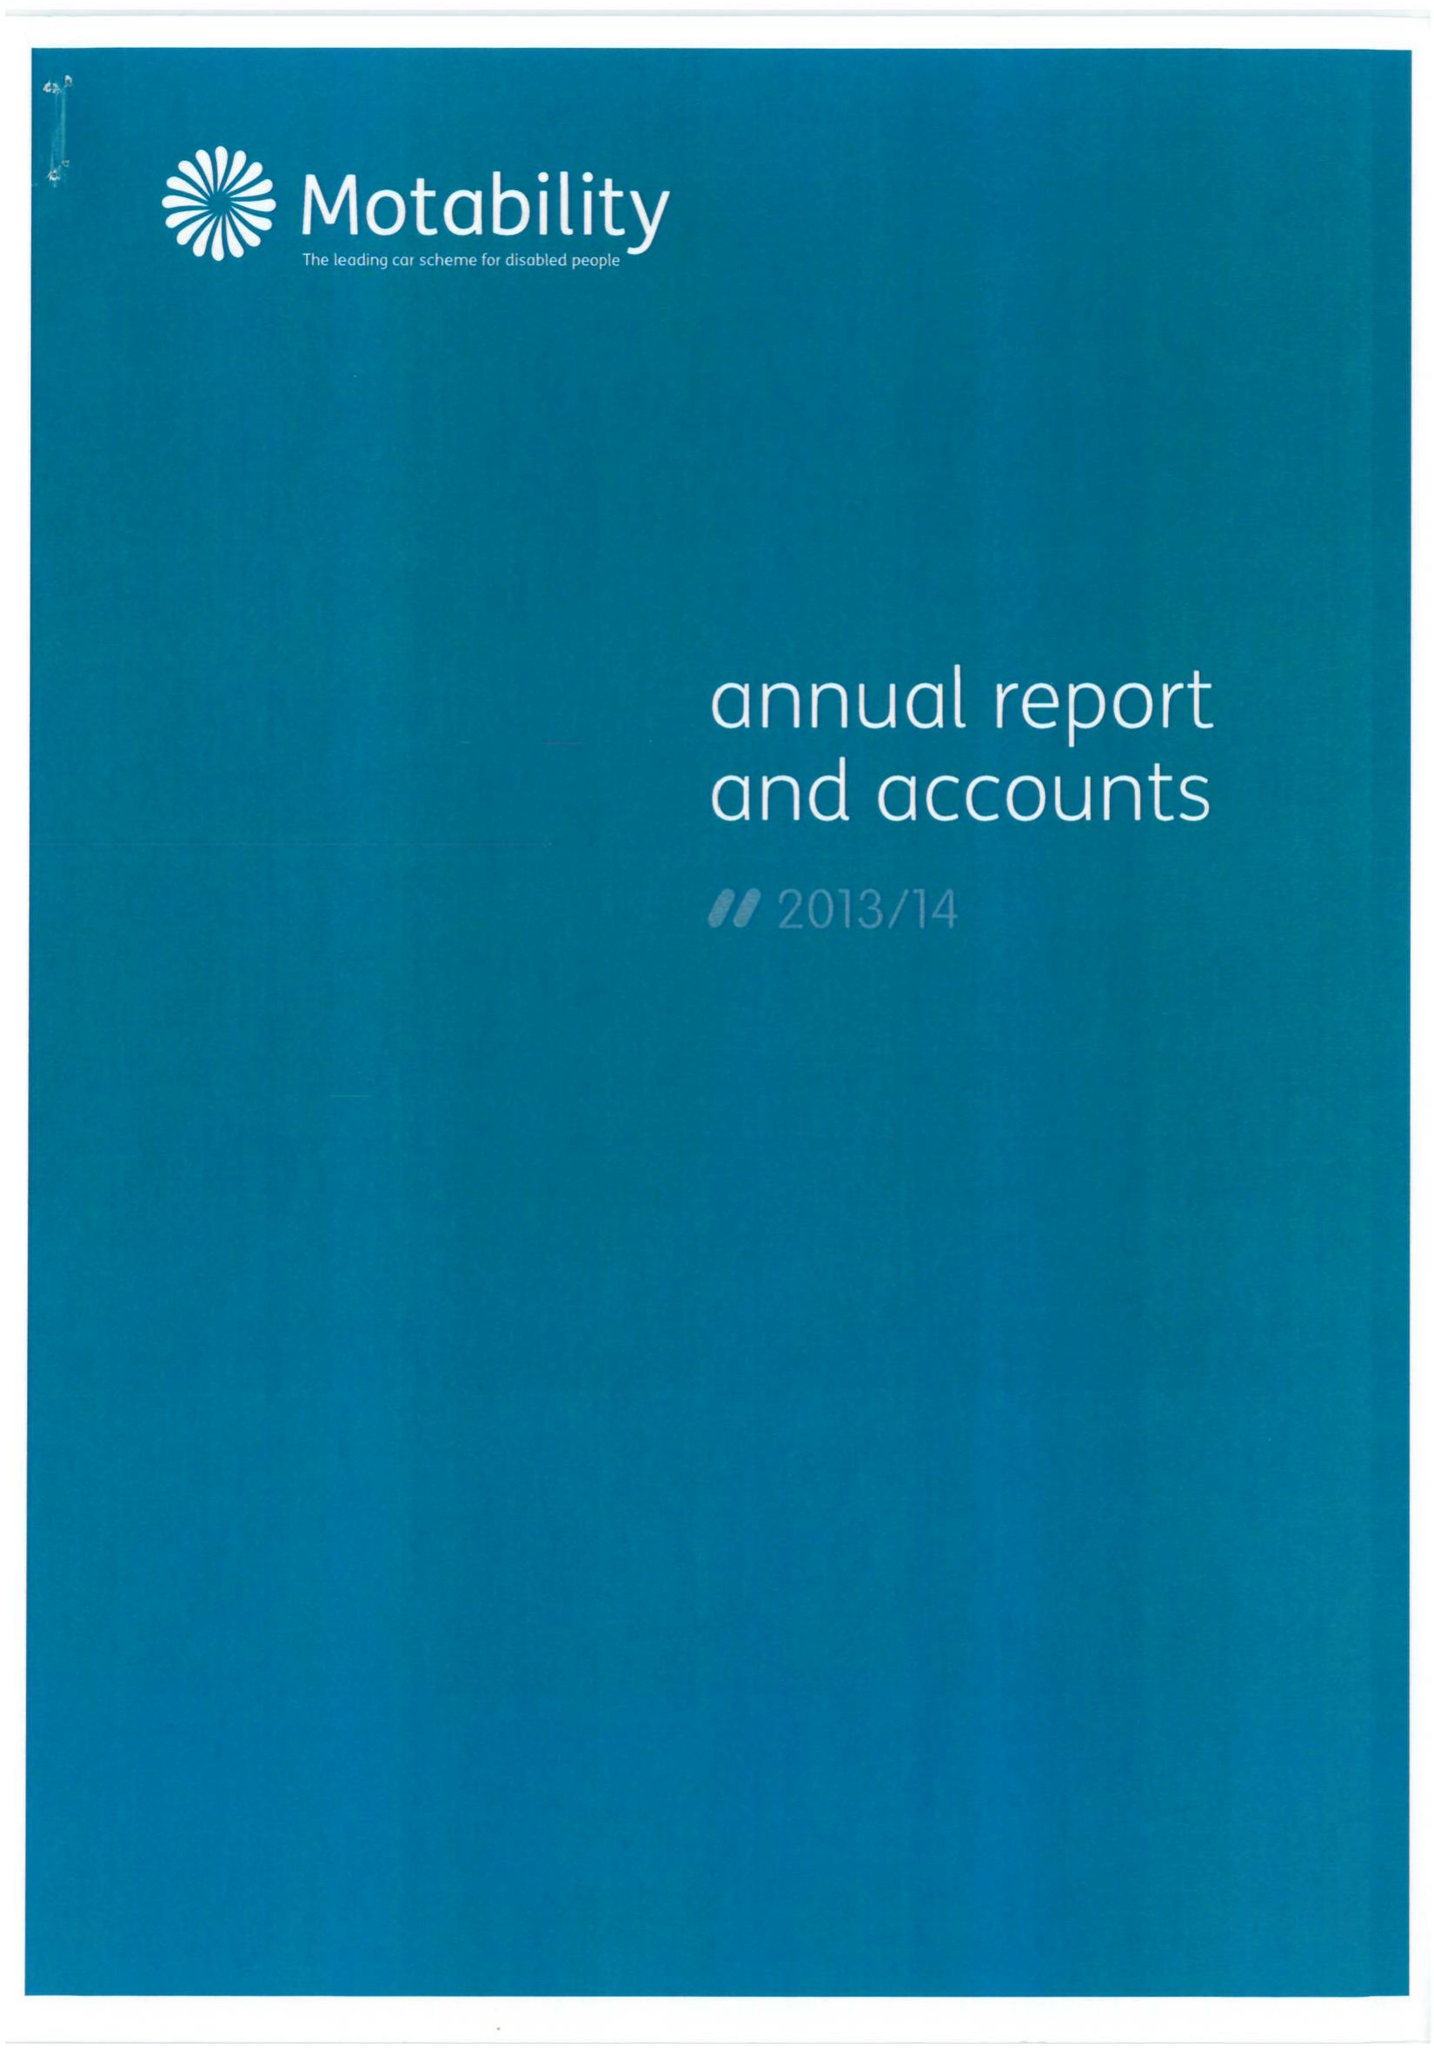What is the value for the address__postcode?
Answer the question using a single word or phrase. CM19 5PX 